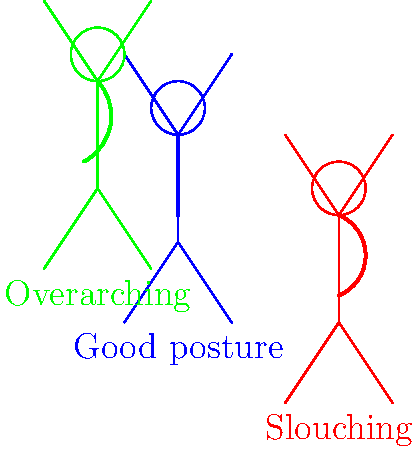Based on the diagram showing three different seating positions, which posture is most likely to cause long-term back pain and potentially lead to costly medical treatments? Consider the financial implications for an indebted consumer. To answer this question, let's analyze each posture and its potential impact on back health:

1. Blue figure (Good posture):
   - Spine is in a natural S-curve
   - Weight is evenly distributed
   - Minimal strain on back muscles and ligaments
   - Least likely to cause long-term issues

2. Green figure (Overarching):
   - Excessive curve in the lower back (hyperlordosis)
   - Increased pressure on the lumbar spine
   - Can lead to muscle strain and fatigue
   - May cause issues over time, but less severe than slouching

3. Red figure (Slouching):
   - Flattened lower back curve
   - Increased pressure on intervertebral discs
   - Stretches spinal ligaments and strains back muscles
   - Highest risk of long-term back pain and disc herniation

Considering the financial implications for an indebted consumer:
- Slouching poses the highest risk of developing chronic back problems
- Chronic back pain often requires ongoing medical treatment, including:
  a) Regular doctor visits
  b) Physiotherapy sessions
  c) Medication costs
  d) Potential surgical interventions in severe cases
- These medical expenses can significantly burden an already indebted individual

Therefore, the slouching posture (red figure) is most likely to cause long-term back pain and lead to costly medical treatments, making it the most financially risky for an indebted consumer.
Answer: Slouching (red figure) 